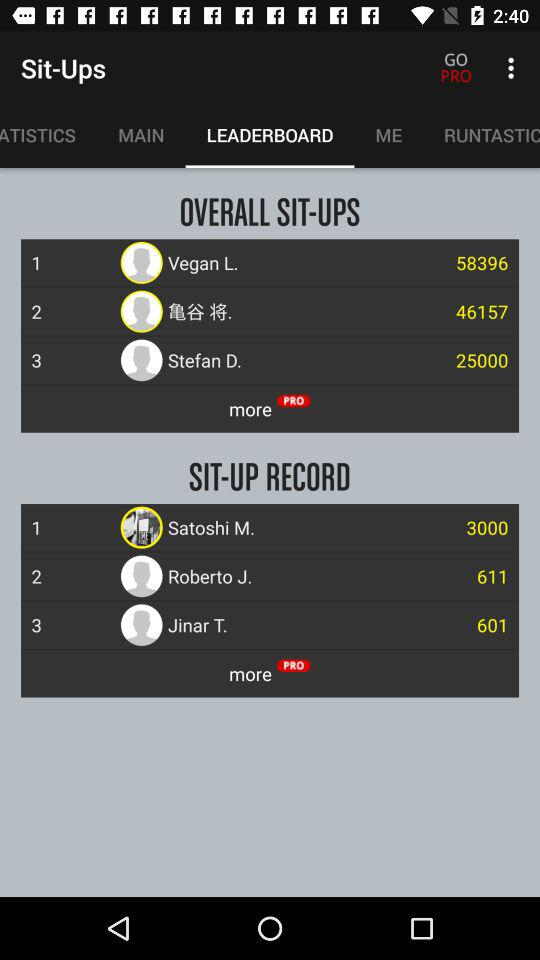How many more sit-ups does the person in 1st place have than the person in 3rd place?
Answer the question using a single word or phrase. 33396 